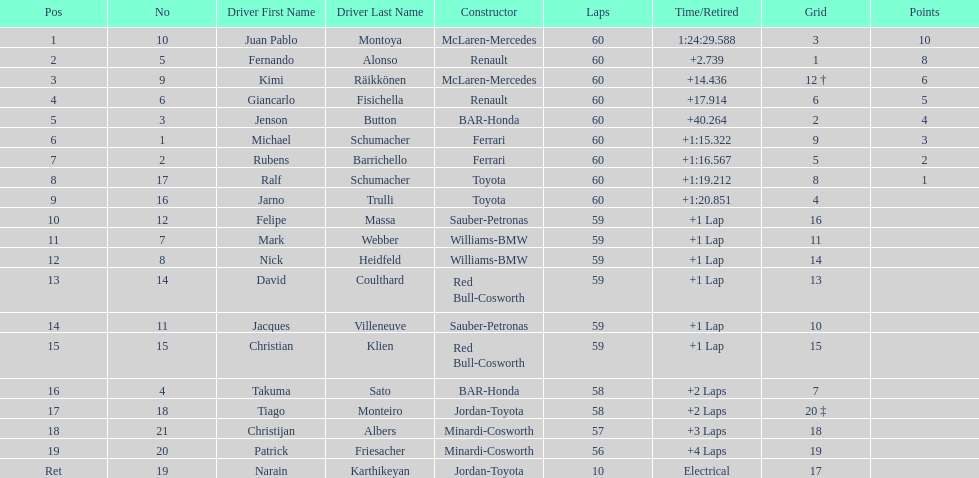What is the number of toyota's on the list? 4. Could you parse the entire table as a dict? {'header': ['Pos', 'No', 'Driver First Name', 'Driver Last Name', 'Constructor', 'Laps', 'Time/Retired', 'Grid', 'Points'], 'rows': [['1', '10', 'Juan Pablo', 'Montoya', 'McLaren-Mercedes', '60', '1:24:29.588', '3', '10'], ['2', '5', 'Fernando', 'Alonso', 'Renault', '60', '+2.739', '1', '8'], ['3', '9', 'Kimi', 'Räikkönen', 'McLaren-Mercedes', '60', '+14.436', '12 †', '6'], ['4', '6', 'Giancarlo', 'Fisichella', 'Renault', '60', '+17.914', '6', '5'], ['5', '3', 'Jenson', 'Button', 'BAR-Honda', '60', '+40.264', '2', '4'], ['6', '1', 'Michael', 'Schumacher', 'Ferrari', '60', '+1:15.322', '9', '3'], ['7', '2', 'Rubens', 'Barrichello', 'Ferrari', '60', '+1:16.567', '5', '2'], ['8', '17', 'Ralf', 'Schumacher', 'Toyota', '60', '+1:19.212', '8', '1'], ['9', '16', 'Jarno', 'Trulli', 'Toyota', '60', '+1:20.851', '4', ''], ['10', '12', 'Felipe', 'Massa', 'Sauber-Petronas', '59', '+1 Lap', '16', ''], ['11', '7', 'Mark', 'Webber', 'Williams-BMW', '59', '+1 Lap', '11', ''], ['12', '8', 'Nick', 'Heidfeld', 'Williams-BMW', '59', '+1 Lap', '14', ''], ['13', '14', 'David', 'Coulthard', 'Red Bull-Cosworth', '59', '+1 Lap', '13', ''], ['14', '11', 'Jacques', 'Villeneuve', 'Sauber-Petronas', '59', '+1 Lap', '10', ''], ['15', '15', 'Christian', 'Klien', 'Red Bull-Cosworth', '59', '+1 Lap', '15', ''], ['16', '4', 'Takuma', 'Sato', 'BAR-Honda', '58', '+2 Laps', '7', ''], ['17', '18', 'Tiago', 'Monteiro', 'Jordan-Toyota', '58', '+2 Laps', '20 ‡', ''], ['18', '21', 'Christijan', 'Albers', 'Minardi-Cosworth', '57', '+3 Laps', '18', ''], ['19', '20', 'Patrick', 'Friesacher', 'Minardi-Cosworth', '56', '+4 Laps', '19', ''], ['Ret', '19', 'Narain', 'Karthikeyan', 'Jordan-Toyota', '10', 'Electrical', '17', '']]} 